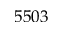<formula> <loc_0><loc_0><loc_500><loc_500>5 5 0 3</formula> 